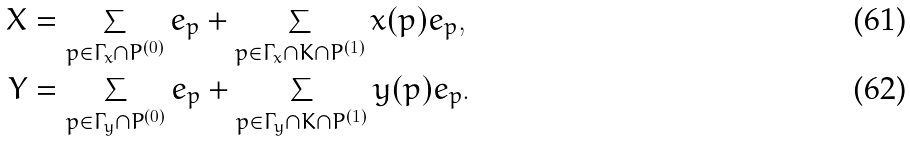<formula> <loc_0><loc_0><loc_500><loc_500>X & = \sum _ { p \in \Gamma _ { x } \cap P ^ { ( 0 ) } } e _ { p } + \sum _ { p \in \Gamma _ { x } \cap K \cap P ^ { ( 1 ) } } x ( p ) e _ { p } , \\ Y & = \sum _ { p \in \Gamma _ { y } \cap P ^ { ( 0 ) } } e _ { p } + \sum _ { p \in \Gamma _ { y } \cap K \cap P ^ { ( 1 ) } } y ( p ) e _ { p } .</formula> 